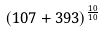Convert formula to latex. <formula><loc_0><loc_0><loc_500><loc_500>( 1 0 7 + 3 9 3 ) ^ { \frac { 1 0 } { 1 0 } }</formula> 